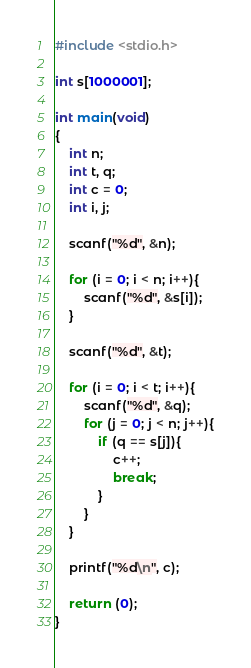Convert code to text. <code><loc_0><loc_0><loc_500><loc_500><_C_>#include <stdio.h>

int s[1000001];

int main(void)
{
	int n;
	int t, q;
	int c = 0;
	int i, j;
	
	scanf("%d", &n);
	
	for (i = 0; i < n; i++){
		scanf("%d", &s[i]);
	}
	
	scanf("%d", &t);
	
	for (i = 0; i < t; i++){
		scanf("%d", &q);
		for (j = 0; j < n; j++){
			if (q == s[j]){
				c++;
				break;
			}
		}
	}
	
	printf("%d\n", c);
	
	return (0);
}</code> 